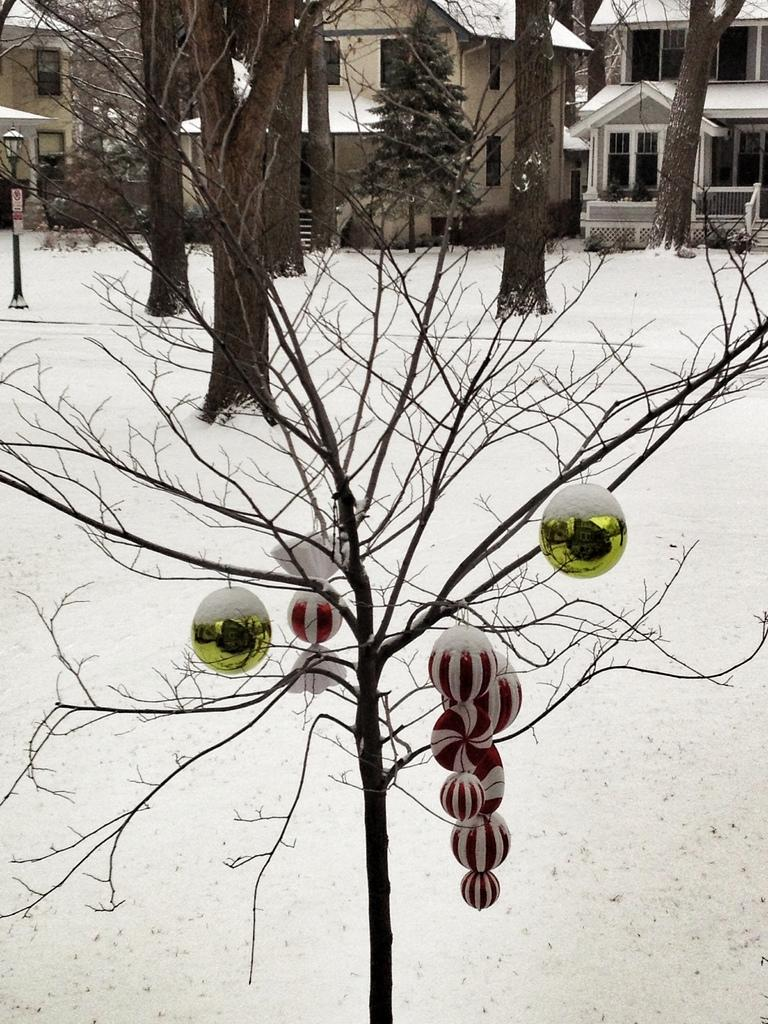What is the condition of the ground in the image? The ground is covered in snow. What type of natural elements can be seen in the image? There are trees in the image. What type of man-made structures are present in the image? There are buildings in the image. Are there any additional features or elements in the image? Yes, there are decorations visible in the image. How many dinosaurs are playing with a ring in the snow in the image? There are no dinosaurs or rings present in the image; it features snow-covered ground, trees, buildings, and decorations. 